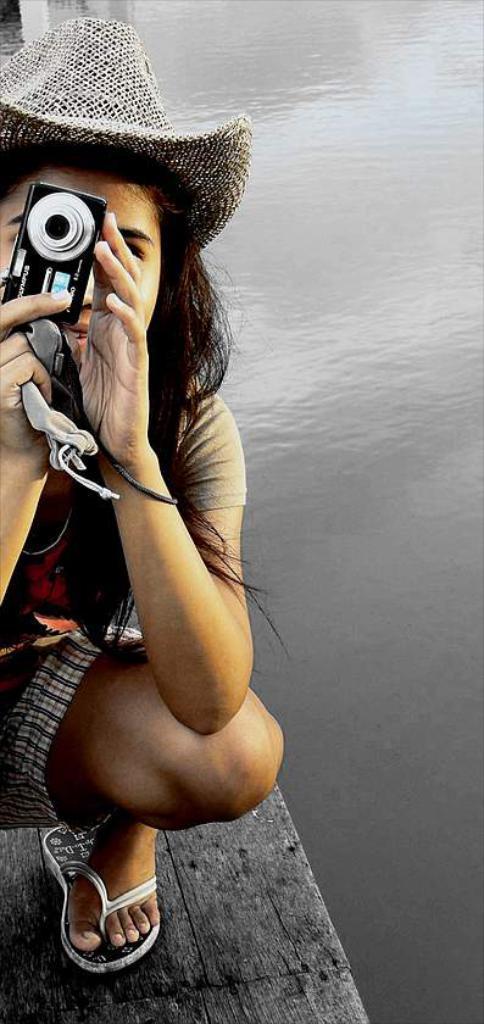How would you summarize this image in a sentence or two? In this picture we can see a woman she is holding a camera in her hands and we can find some water. 